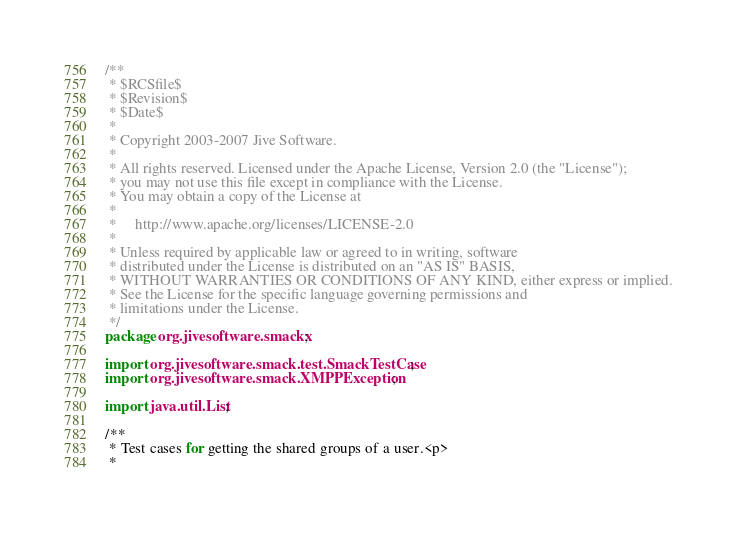<code> <loc_0><loc_0><loc_500><loc_500><_Java_>/**
 * $RCSfile$
 * $Revision$
 * $Date$
 *
 * Copyright 2003-2007 Jive Software.
 *
 * All rights reserved. Licensed under the Apache License, Version 2.0 (the "License");
 * you may not use this file except in compliance with the License.
 * You may obtain a copy of the License at
 *
 *     http://www.apache.org/licenses/LICENSE-2.0
 *
 * Unless required by applicable law or agreed to in writing, software
 * distributed under the License is distributed on an "AS IS" BASIS,
 * WITHOUT WARRANTIES OR CONDITIONS OF ANY KIND, either express or implied.
 * See the License for the specific language governing permissions and
 * limitations under the License.
 */
package org.jivesoftware.smackx;

import org.jivesoftware.smack.test.SmackTestCase;
import org.jivesoftware.smack.XMPPException;

import java.util.List;

/**
 * Test cases for getting the shared groups of a user.<p>
 *</code> 